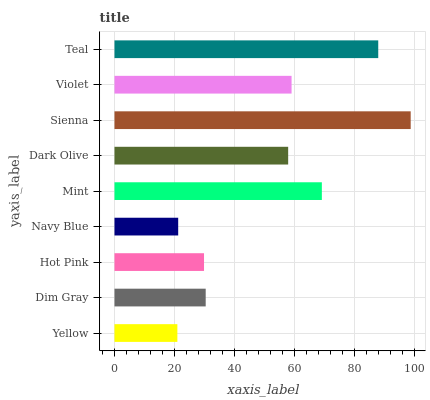Is Yellow the minimum?
Answer yes or no. Yes. Is Sienna the maximum?
Answer yes or no. Yes. Is Dim Gray the minimum?
Answer yes or no. No. Is Dim Gray the maximum?
Answer yes or no. No. Is Dim Gray greater than Yellow?
Answer yes or no. Yes. Is Yellow less than Dim Gray?
Answer yes or no. Yes. Is Yellow greater than Dim Gray?
Answer yes or no. No. Is Dim Gray less than Yellow?
Answer yes or no. No. Is Dark Olive the high median?
Answer yes or no. Yes. Is Dark Olive the low median?
Answer yes or no. Yes. Is Violet the high median?
Answer yes or no. No. Is Yellow the low median?
Answer yes or no. No. 